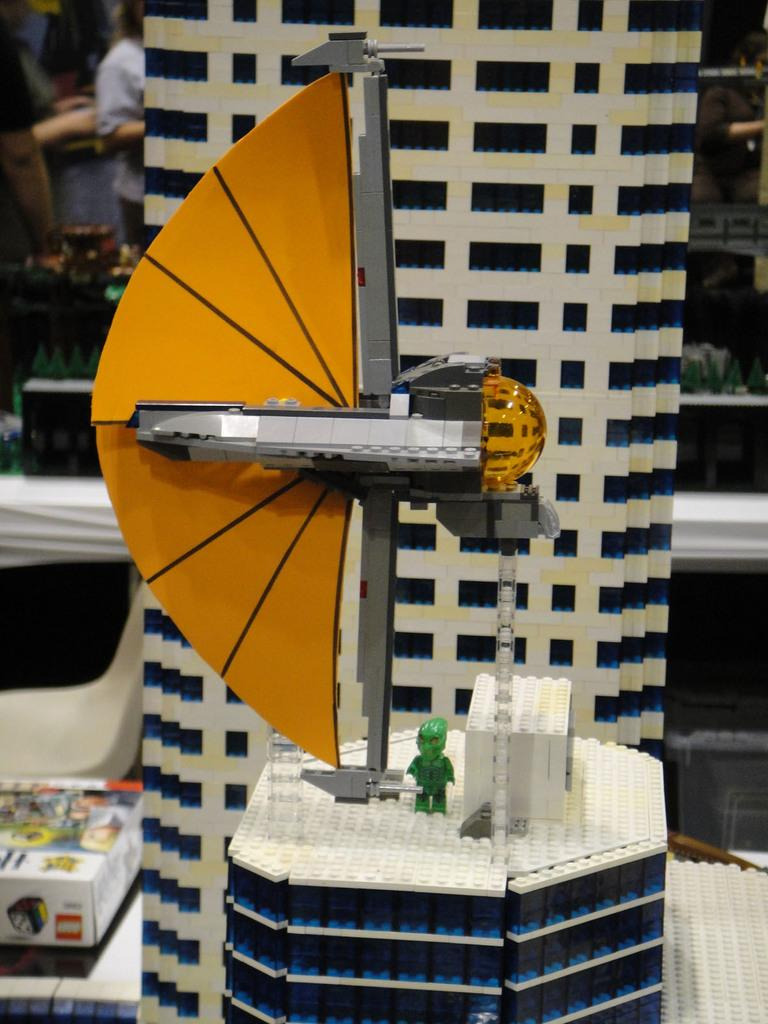What is the main subject of the image? The main subject of the image is a scale model. Can you describe the background of the image? The background of the image is blurred. How many rabbits can be seen receiving a reward in the image? There are no rabbits or rewards present in the image. 